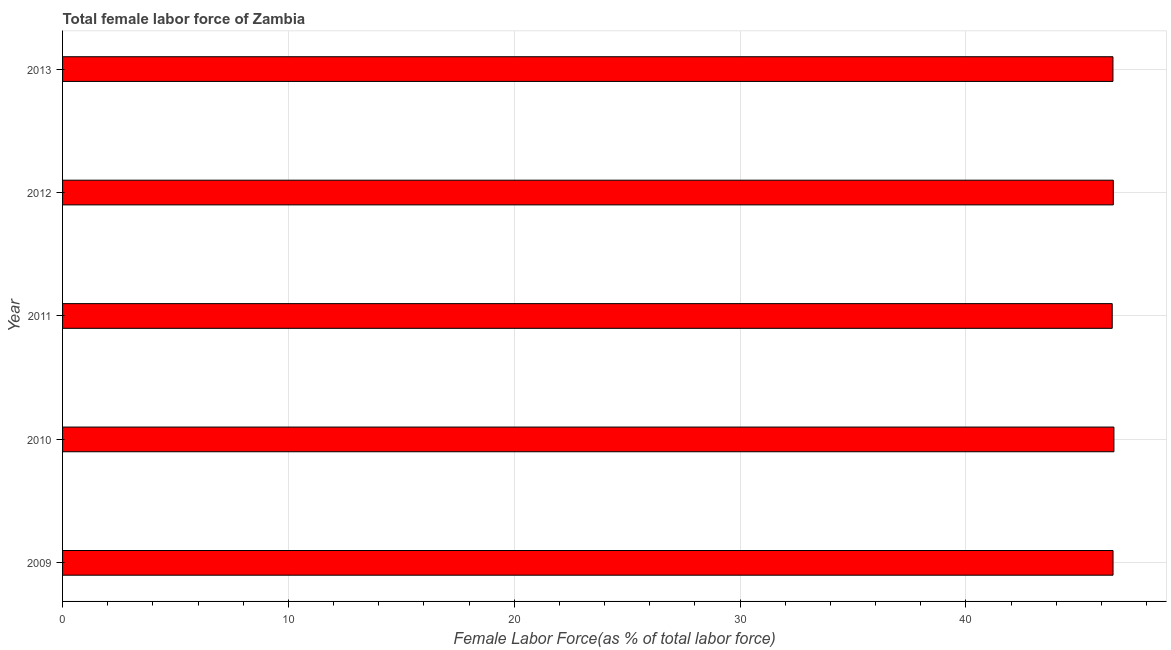Does the graph contain any zero values?
Offer a very short reply. No. Does the graph contain grids?
Provide a short and direct response. Yes. What is the title of the graph?
Your response must be concise. Total female labor force of Zambia. What is the label or title of the X-axis?
Offer a very short reply. Female Labor Force(as % of total labor force). What is the total female labor force in 2009?
Ensure brevity in your answer.  46.51. Across all years, what is the maximum total female labor force?
Your answer should be very brief. 46.55. Across all years, what is the minimum total female labor force?
Make the answer very short. 46.48. In which year was the total female labor force maximum?
Offer a very short reply. 2010. In which year was the total female labor force minimum?
Keep it short and to the point. 2011. What is the sum of the total female labor force?
Your response must be concise. 232.58. What is the difference between the total female labor force in 2009 and 2012?
Your response must be concise. -0.01. What is the average total female labor force per year?
Provide a succinct answer. 46.52. What is the median total female labor force?
Offer a terse response. 46.51. What is the ratio of the total female labor force in 2009 to that in 2013?
Make the answer very short. 1. Is the difference between the total female labor force in 2009 and 2012 greater than the difference between any two years?
Offer a terse response. No. What is the difference between the highest and the second highest total female labor force?
Keep it short and to the point. 0.03. What is the difference between the highest and the lowest total female labor force?
Offer a terse response. 0.08. Are all the bars in the graph horizontal?
Your answer should be very brief. Yes. Are the values on the major ticks of X-axis written in scientific E-notation?
Make the answer very short. No. What is the Female Labor Force(as % of total labor force) of 2009?
Keep it short and to the point. 46.51. What is the Female Labor Force(as % of total labor force) of 2010?
Keep it short and to the point. 46.55. What is the Female Labor Force(as % of total labor force) of 2011?
Ensure brevity in your answer.  46.48. What is the Female Labor Force(as % of total labor force) of 2012?
Your answer should be very brief. 46.53. What is the Female Labor Force(as % of total labor force) in 2013?
Make the answer very short. 46.51. What is the difference between the Female Labor Force(as % of total labor force) in 2009 and 2010?
Keep it short and to the point. -0.04. What is the difference between the Female Labor Force(as % of total labor force) in 2009 and 2011?
Make the answer very short. 0.04. What is the difference between the Female Labor Force(as % of total labor force) in 2009 and 2012?
Your answer should be very brief. -0.01. What is the difference between the Female Labor Force(as % of total labor force) in 2009 and 2013?
Ensure brevity in your answer.  0. What is the difference between the Female Labor Force(as % of total labor force) in 2010 and 2011?
Offer a terse response. 0.08. What is the difference between the Female Labor Force(as % of total labor force) in 2010 and 2012?
Give a very brief answer. 0.03. What is the difference between the Female Labor Force(as % of total labor force) in 2010 and 2013?
Provide a short and direct response. 0.04. What is the difference between the Female Labor Force(as % of total labor force) in 2011 and 2012?
Provide a short and direct response. -0.05. What is the difference between the Female Labor Force(as % of total labor force) in 2011 and 2013?
Offer a very short reply. -0.03. What is the difference between the Female Labor Force(as % of total labor force) in 2012 and 2013?
Offer a very short reply. 0.01. What is the ratio of the Female Labor Force(as % of total labor force) in 2009 to that in 2012?
Make the answer very short. 1. What is the ratio of the Female Labor Force(as % of total labor force) in 2010 to that in 2011?
Offer a very short reply. 1. What is the ratio of the Female Labor Force(as % of total labor force) in 2010 to that in 2012?
Provide a short and direct response. 1. What is the ratio of the Female Labor Force(as % of total labor force) in 2011 to that in 2013?
Provide a short and direct response. 1. What is the ratio of the Female Labor Force(as % of total labor force) in 2012 to that in 2013?
Provide a short and direct response. 1. 